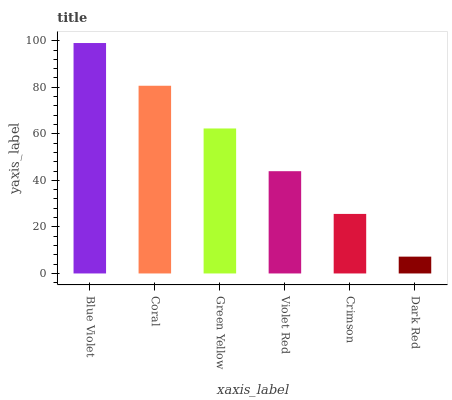Is Dark Red the minimum?
Answer yes or no. Yes. Is Blue Violet the maximum?
Answer yes or no. Yes. Is Coral the minimum?
Answer yes or no. No. Is Coral the maximum?
Answer yes or no. No. Is Blue Violet greater than Coral?
Answer yes or no. Yes. Is Coral less than Blue Violet?
Answer yes or no. Yes. Is Coral greater than Blue Violet?
Answer yes or no. No. Is Blue Violet less than Coral?
Answer yes or no. No. Is Green Yellow the high median?
Answer yes or no. Yes. Is Violet Red the low median?
Answer yes or no. Yes. Is Violet Red the high median?
Answer yes or no. No. Is Coral the low median?
Answer yes or no. No. 